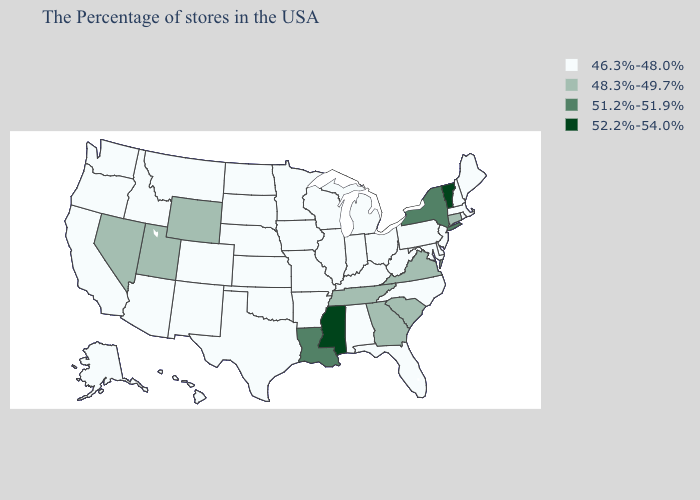Which states have the lowest value in the USA?
Keep it brief. Maine, Massachusetts, Rhode Island, New Hampshire, New Jersey, Delaware, Maryland, Pennsylvania, North Carolina, West Virginia, Ohio, Florida, Michigan, Kentucky, Indiana, Alabama, Wisconsin, Illinois, Missouri, Arkansas, Minnesota, Iowa, Kansas, Nebraska, Oklahoma, Texas, South Dakota, North Dakota, Colorado, New Mexico, Montana, Arizona, Idaho, California, Washington, Oregon, Alaska, Hawaii. Among the states that border Utah , does Wyoming have the lowest value?
Write a very short answer. No. What is the value of Wisconsin?
Give a very brief answer. 46.3%-48.0%. What is the value of Michigan?
Write a very short answer. 46.3%-48.0%. What is the value of Rhode Island?
Give a very brief answer. 46.3%-48.0%. What is the value of Alabama?
Be succinct. 46.3%-48.0%. Among the states that border Maine , which have the highest value?
Give a very brief answer. New Hampshire. Does Utah have the highest value in the West?
Short answer required. Yes. Name the states that have a value in the range 52.2%-54.0%?
Short answer required. Vermont, Mississippi. What is the value of Washington?
Quick response, please. 46.3%-48.0%. What is the value of Montana?
Be succinct. 46.3%-48.0%. What is the lowest value in the USA?
Answer briefly. 46.3%-48.0%. Among the states that border Washington , which have the highest value?
Short answer required. Idaho, Oregon. What is the value of Texas?
Quick response, please. 46.3%-48.0%. 